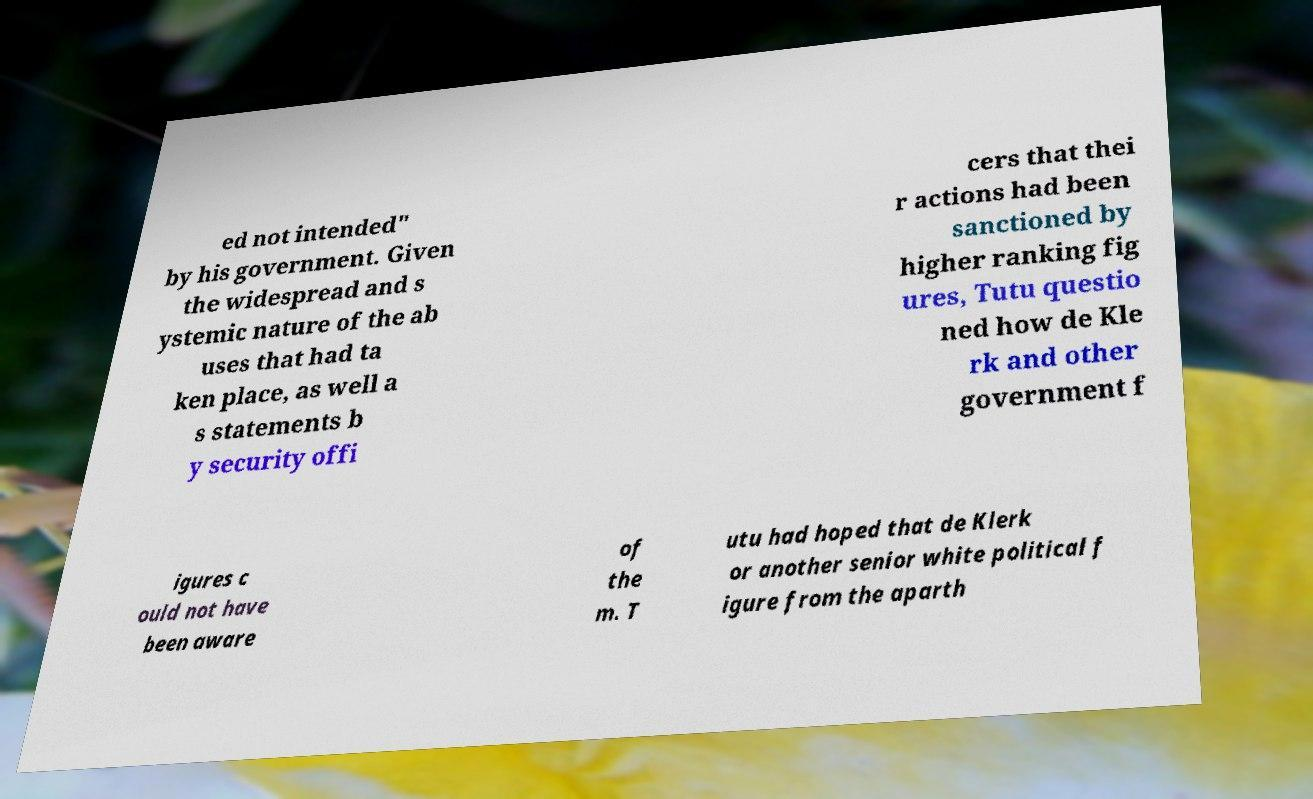Can you accurately transcribe the text from the provided image for me? ed not intended" by his government. Given the widespread and s ystemic nature of the ab uses that had ta ken place, as well a s statements b y security offi cers that thei r actions had been sanctioned by higher ranking fig ures, Tutu questio ned how de Kle rk and other government f igures c ould not have been aware of the m. T utu had hoped that de Klerk or another senior white political f igure from the aparth 